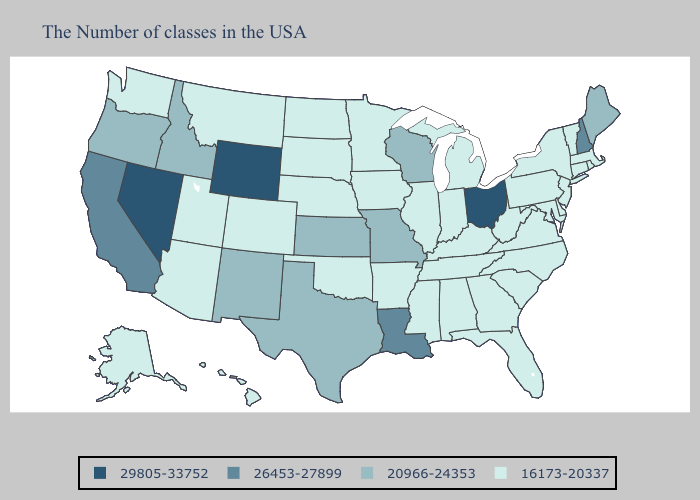Does North Carolina have the highest value in the South?
Concise answer only. No. Does Indiana have a lower value than Alaska?
Keep it brief. No. Among the states that border Minnesota , which have the lowest value?
Answer briefly. Iowa, South Dakota, North Dakota. Does Ohio have the highest value in the USA?
Give a very brief answer. Yes. Does Massachusetts have the lowest value in the USA?
Answer briefly. Yes. What is the highest value in the USA?
Keep it brief. 29805-33752. Does Indiana have the highest value in the USA?
Answer briefly. No. What is the lowest value in the MidWest?
Answer briefly. 16173-20337. Does Wisconsin have the lowest value in the MidWest?
Concise answer only. No. What is the value of Arkansas?
Answer briefly. 16173-20337. What is the highest value in states that border Iowa?
Be succinct. 20966-24353. Does Wyoming have the lowest value in the USA?
Give a very brief answer. No. Does the first symbol in the legend represent the smallest category?
Quick response, please. No. Does Louisiana have the highest value in the South?
Short answer required. Yes. Which states have the highest value in the USA?
Concise answer only. Ohio, Wyoming, Nevada. 